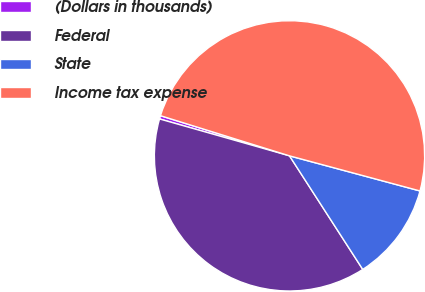<chart> <loc_0><loc_0><loc_500><loc_500><pie_chart><fcel>(Dollars in thousands)<fcel>Federal<fcel>State<fcel>Income tax expense<nl><fcel>0.4%<fcel>38.52%<fcel>11.7%<fcel>49.38%<nl></chart> 